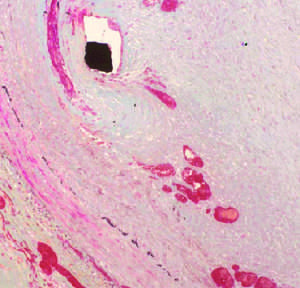what shows a thickened neointima overlying the stent wires black diamond encroaches on the lumen asterisk?
Answer the question using a single word or phrase. Histologic view 